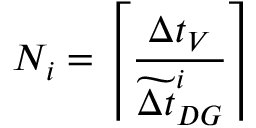<formula> <loc_0><loc_0><loc_500><loc_500>N _ { i } = \left \lceil \frac { \Delta t _ { V } } { \widetilde { \Delta t } _ { D G } ^ { i } } \right \rceil</formula> 